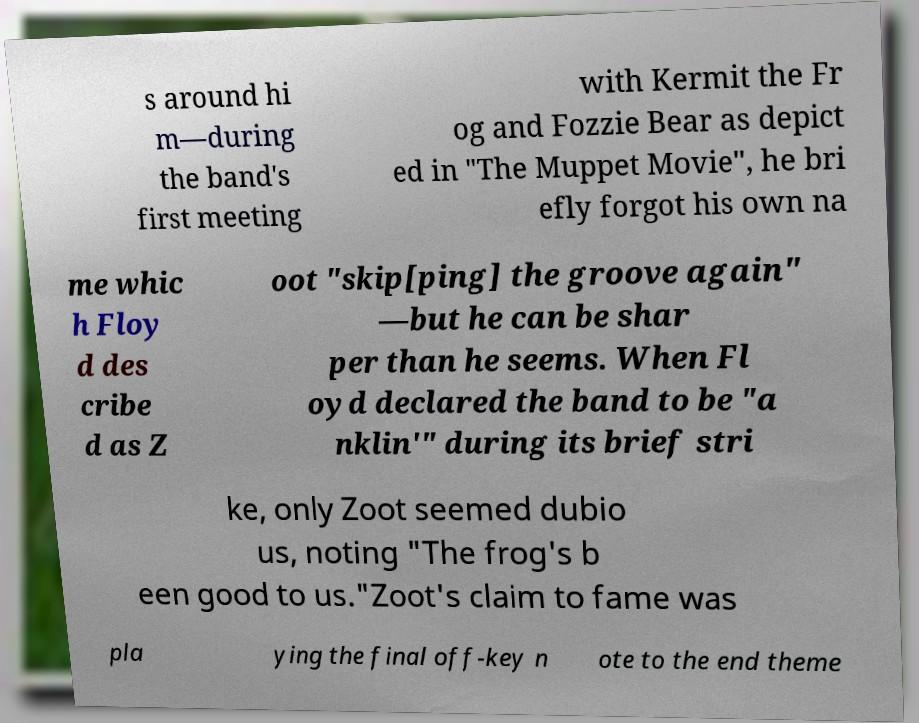Could you assist in decoding the text presented in this image and type it out clearly? s around hi m—during the band's first meeting with Kermit the Fr og and Fozzie Bear as depict ed in "The Muppet Movie", he bri efly forgot his own na me whic h Floy d des cribe d as Z oot "skip[ping] the groove again" —but he can be shar per than he seems. When Fl oyd declared the band to be "a nklin'" during its brief stri ke, only Zoot seemed dubio us, noting "The frog's b een good to us."Zoot's claim to fame was pla ying the final off-key n ote to the end theme 